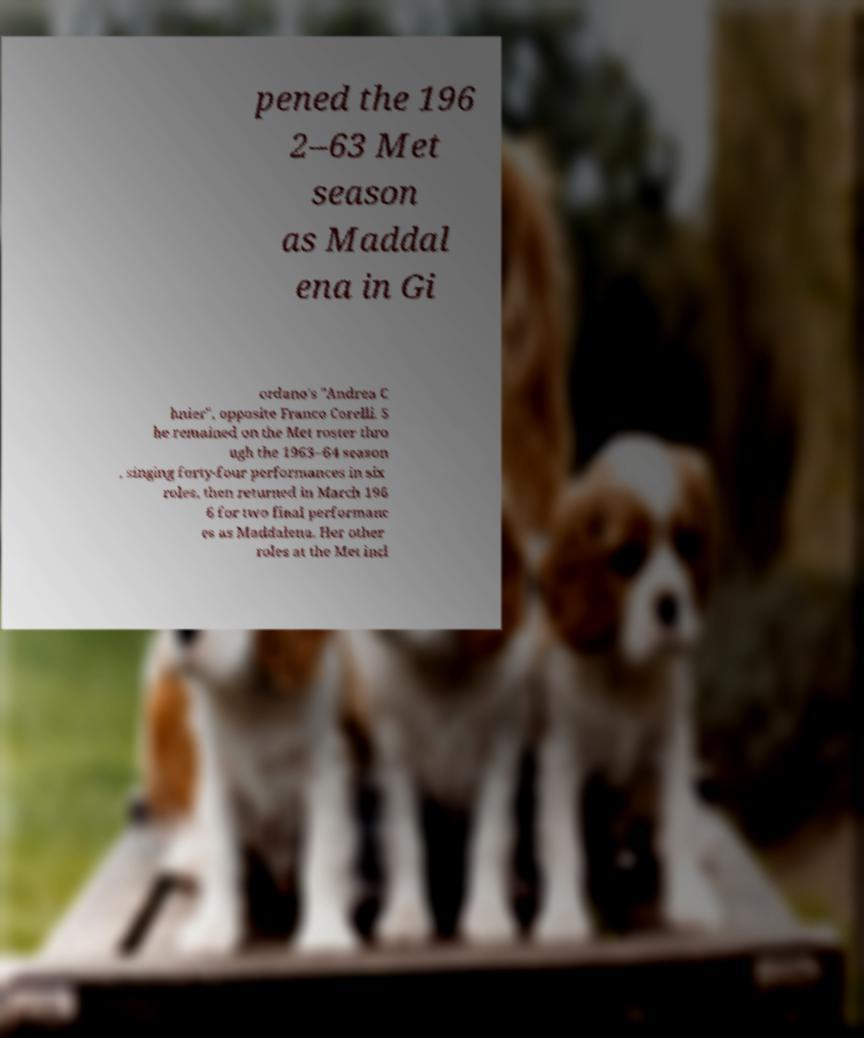What messages or text are displayed in this image? I need them in a readable, typed format. pened the 196 2–63 Met season as Maddal ena in Gi ordano's "Andrea C hnier", opposite Franco Corelli. S he remained on the Met roster thro ugh the 1963–64 season , singing forty-four performances in six roles, then returned in March 196 6 for two final performanc es as Maddalena. Her other roles at the Met incl 